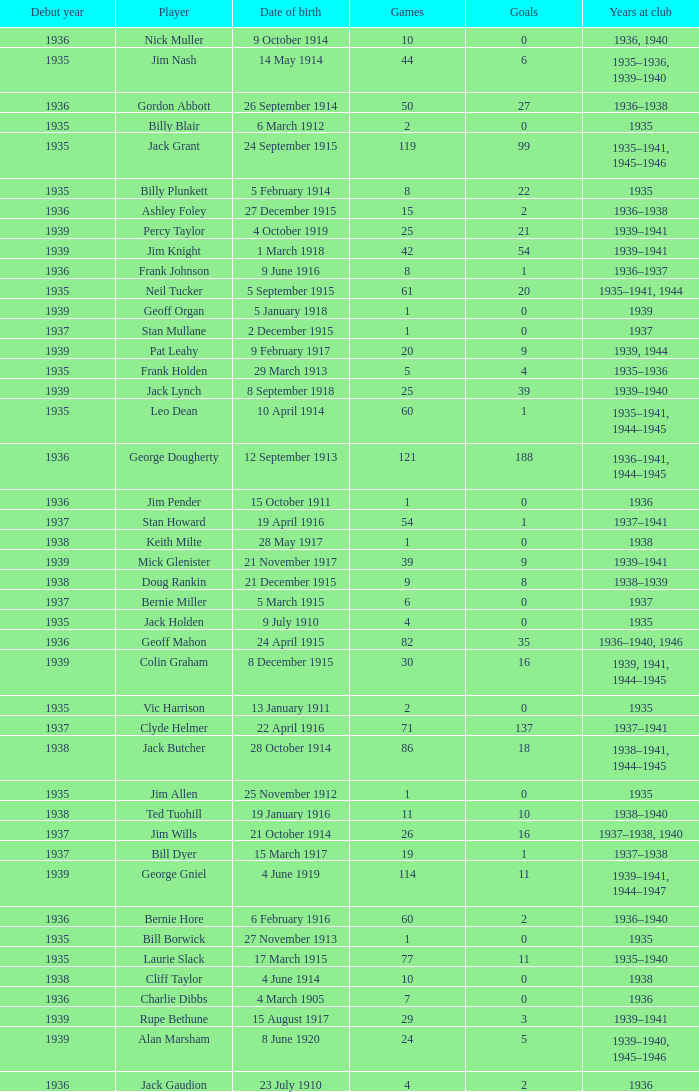How many years has the player who scored 2 goals and was born on july 23, 1910, been at the club? 1936.0. 